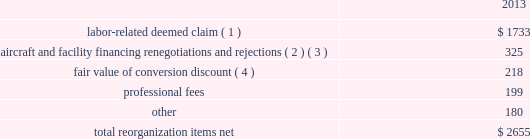Table of contents extinguishment costs incurred as a result of the repayment of certain aircraft secured indebtedness , including cash interest charges and non-cash write offs of unamortized debt issuance costs .
As a result of the 2013 refinancing activities and the early extinguishment of american 2019s 7.50% ( 7.50 % ) senior secured notes in 2014 , we recognized $ 100 million less interest expense in 2014 as compared to the 2013 period .
Other nonoperating expense , net in 2014 consisted principally of net foreign currency losses of $ 114 million and early debt extinguishment charges of $ 56 million .
Other nonoperating expense , net in 2013 consisted principally of net foreign currency losses of $ 56 million and early debt extinguishment charges of $ 29 million .
Other nonoperating expense , net increased $ 64 million , or 73.1% ( 73.1 % ) , during 2014 primarily due to special charges recognized as a result of early debt extinguishment and an increase in foreign currency losses driven by the strengthening of the u.s .
Dollar in foreign currency transactions , principally in latin american markets .
We recorded a $ 43 million special charge for venezuelan foreign currency losses in 2014 .
See part ii , item 7a .
Quantitative and qualitative disclosures about market risk for further discussion of our cash held in venezuelan bolivars .
In addition , our 2014 nonoperating special items included $ 56 million primarily related to the early extinguishment of american 2019s 7.50% ( 7.50 % ) senior secured notes and other indebtedness .
Reorganization items , net reorganization items refer to revenues , expenses ( including professional fees ) , realized gains and losses and provisions for losses that are realized or incurred as a direct result of the chapter 11 cases .
The table summarizes the components included in reorganization items , net on aag 2019s consolidated statement of operations for the year ended december 31 , 2013 ( in millions ) : .
( 1 ) in exchange for employees 2019 contributions to the successful reorganization , including agreeing to reductions in pay and benefits , we agreed in the plan to provide each employee group a deemed claim , which was used to provide a distribution of a portion of the equity of the reorganized entity to those employees .
Each employee group received a deemed claim amount based upon a portion of the value of cost savings provided by that group through reductions to pay and benefits as well as through certain work rule changes .
The total value of this deemed claim was approximately $ 1.7 billion .
( 2 ) amounts include allowed claims ( claims approved by the bankruptcy court ) and estimated allowed claims relating to ( i ) the rejection or modification of financings related to aircraft and ( ii ) entry of orders treated as unsecured claims with respect to facility agreements supporting certain issuances of special facility revenue bonds .
The debtors recorded an estimated claim associated with the rejection or modification of a financing or facility agreement when the applicable motion was filed with the bankruptcy court to reject or modify such financing or facility agreement and the debtors believed that it was probable the motion would be approved , and there was sufficient information to estimate the claim .
See note 2 to aag 2019s consolidated financial statements in part ii , item 8a for further information .
( 3 ) pursuant to the plan , the debtors agreed to allow certain post-petition unsecured claims on obligations .
As a result , during the year ended december 31 , 2013 , we recorded reorganization charges to adjust estimated allowed claim amounts previously recorded on rejected special facility revenue bonds of $ 180 million , allowed general unsecured claims related to the 1990 and 1994 series of special facility revenue bonds that financed certain improvements at jfk , and rejected bonds that financed certain improvements at ord , which are included in the table above. .
What was the ratio of the labor-related deemed claim to the professional fees as part of the re-organization? 
Rationale: for every dollar spend on professional fees there $ 8.7 of labor-related deemed claim
Computations: (1733 / 1990)
Answer: 0.87085. 